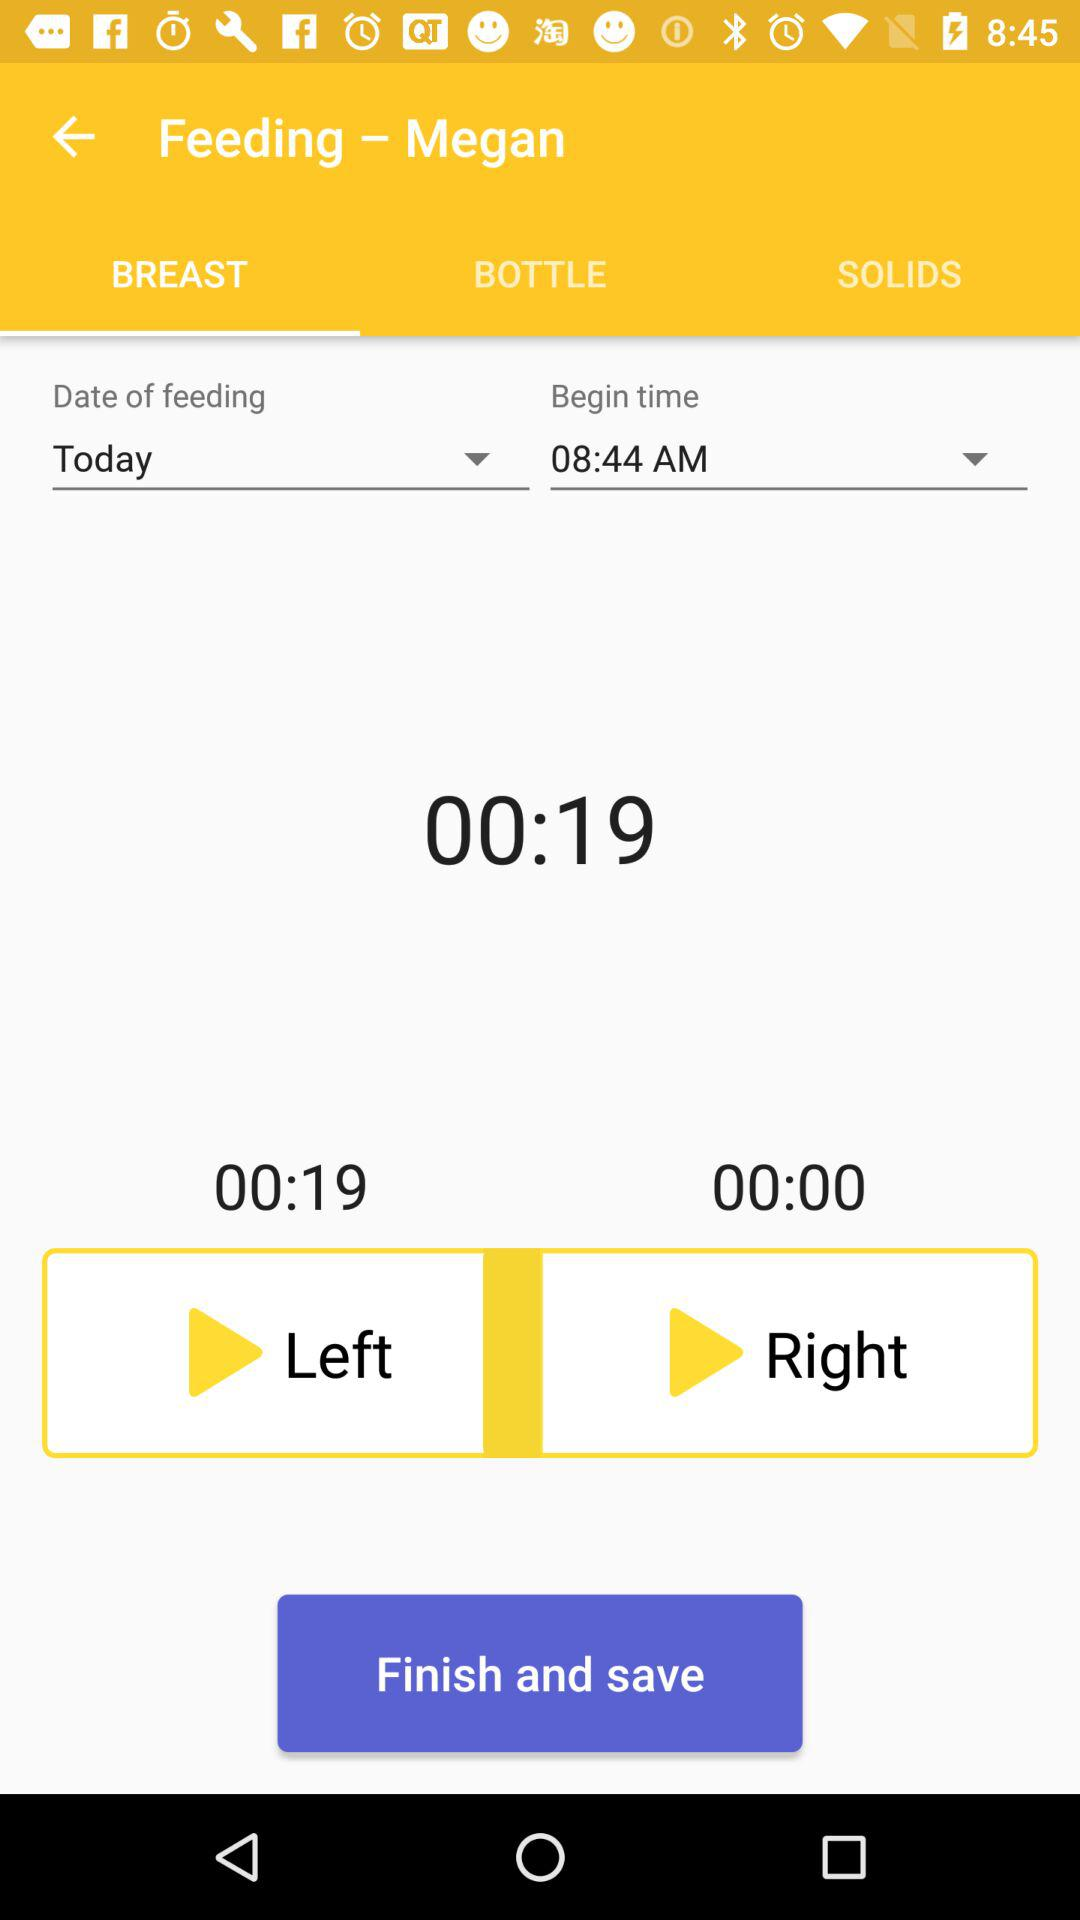What is the duration? The duration is 19 seconds. 